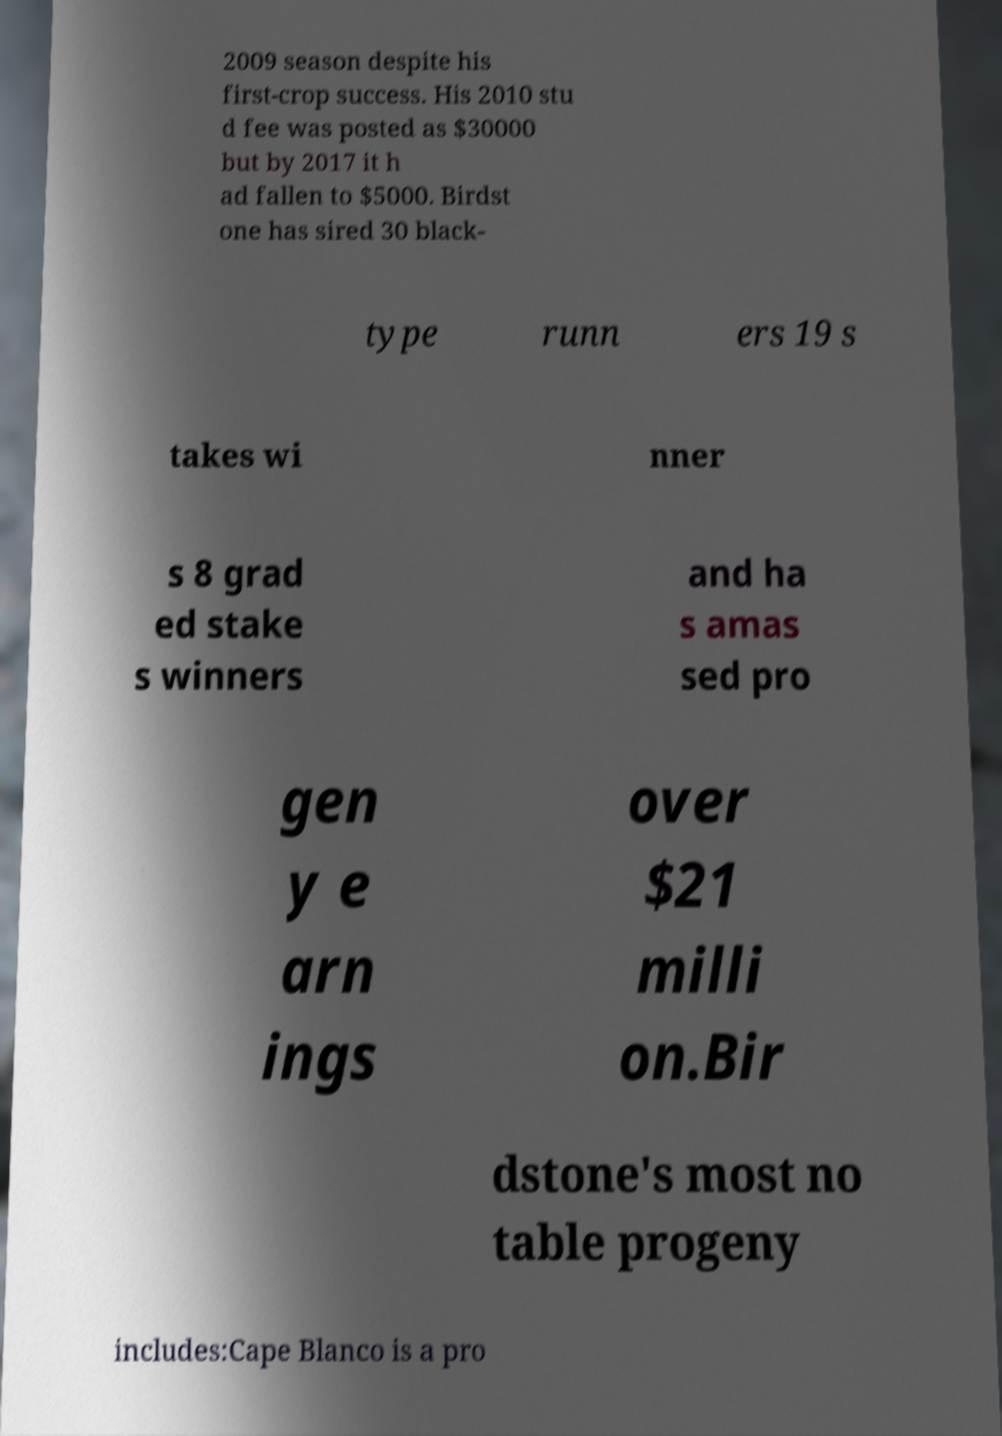For documentation purposes, I need the text within this image transcribed. Could you provide that? 2009 season despite his first-crop success. His 2010 stu d fee was posted as $30000 but by 2017 it h ad fallen to $5000. Birdst one has sired 30 black- type runn ers 19 s takes wi nner s 8 grad ed stake s winners and ha s amas sed pro gen y e arn ings over $21 milli on.Bir dstone's most no table progeny includes:Cape Blanco is a pro 